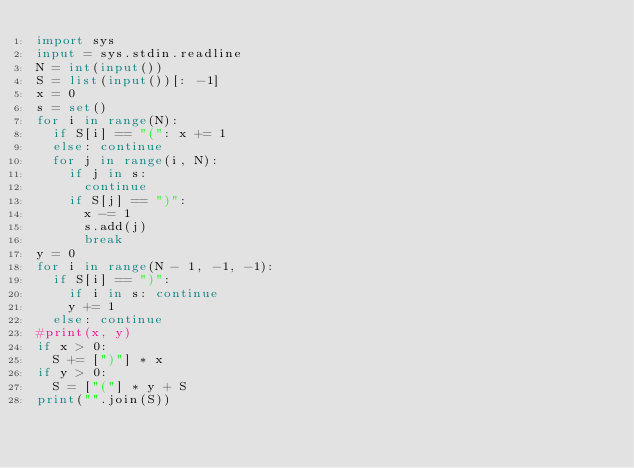Convert code to text. <code><loc_0><loc_0><loc_500><loc_500><_Python_>import sys
input = sys.stdin.readline
N = int(input())
S = list(input())[: -1]
x = 0
s = set()
for i in range(N):
  if S[i] == "(": x += 1
  else: continue
  for j in range(i, N):
    if j in s:
      continue
    if S[j] == ")":
      x -= 1
      s.add(j)
      break
y = 0
for i in range(N - 1, -1, -1):
  if S[i] == ")":
    if i in s: continue
    y += 1
  else: continue
#print(x, y)
if x > 0:
  S += [")"] * x
if y > 0:
  S = ["("] * y + S
print("".join(S))</code> 